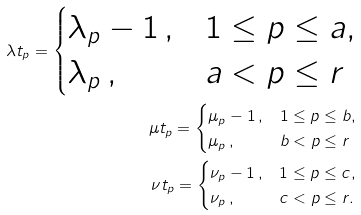Convert formula to latex. <formula><loc_0><loc_0><loc_500><loc_500>\lambda t _ { p } = \begin{cases} \lambda _ { p } - 1 \, , & 1 \leq p \leq a , \\ \lambda _ { p } \, , & a < p \leq r \end{cases} \\ \mu t _ { p } = \begin{cases} \mu _ { p } - 1 \, , & 1 \leq p \leq b , \\ \mu _ { p } \, , & b < p \leq r \end{cases} \\ \nu t _ { p } = \begin{cases} \nu _ { p } - 1 \, , & 1 \leq p \leq c , \\ \nu _ { p } \, , & c < p \leq r . \end{cases}</formula> 